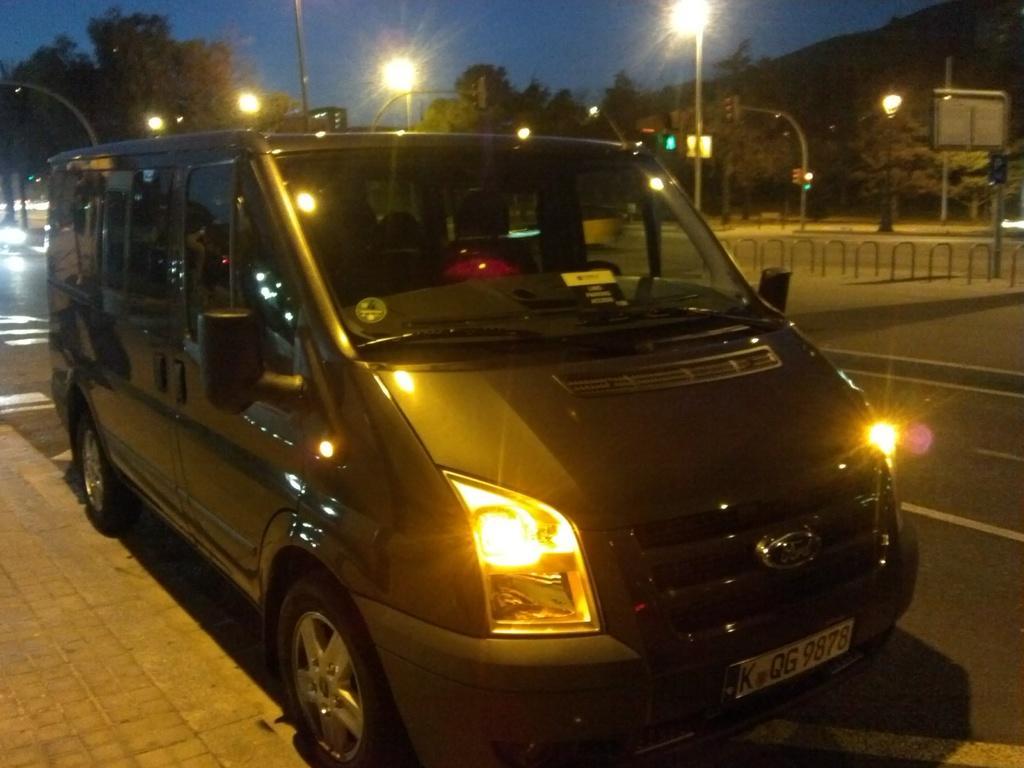Can you describe this image briefly? In this picture we can see vehicle on the road. In the background of the image we can see lights, boards, traffic signal, poles, trees, rods and sky. 